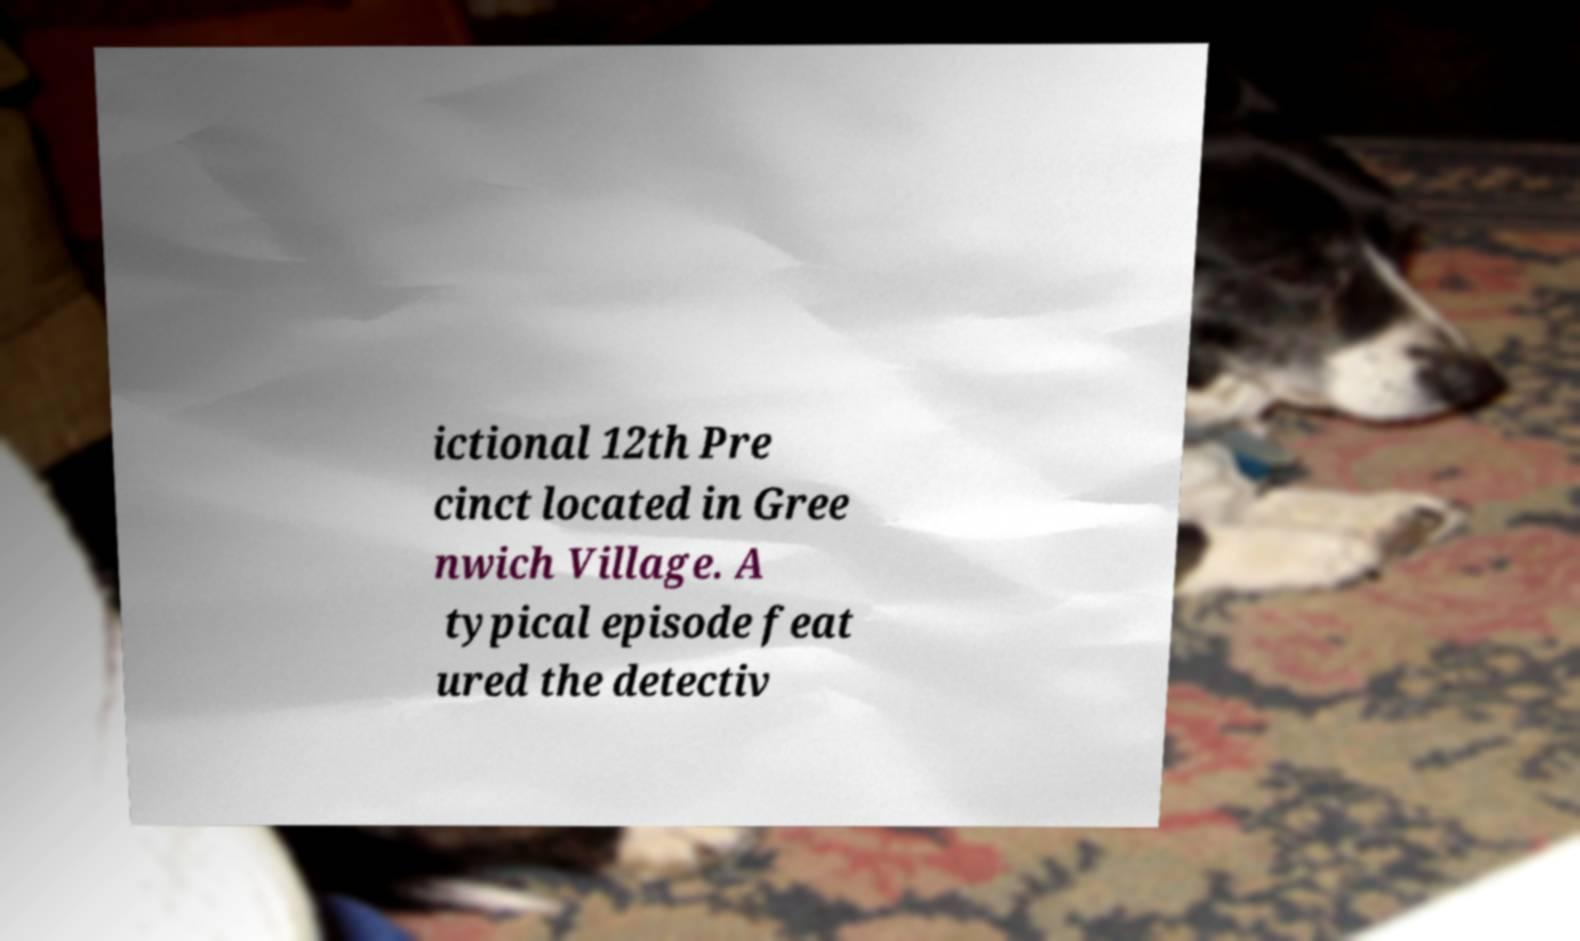Please identify and transcribe the text found in this image. ictional 12th Pre cinct located in Gree nwich Village. A typical episode feat ured the detectiv 